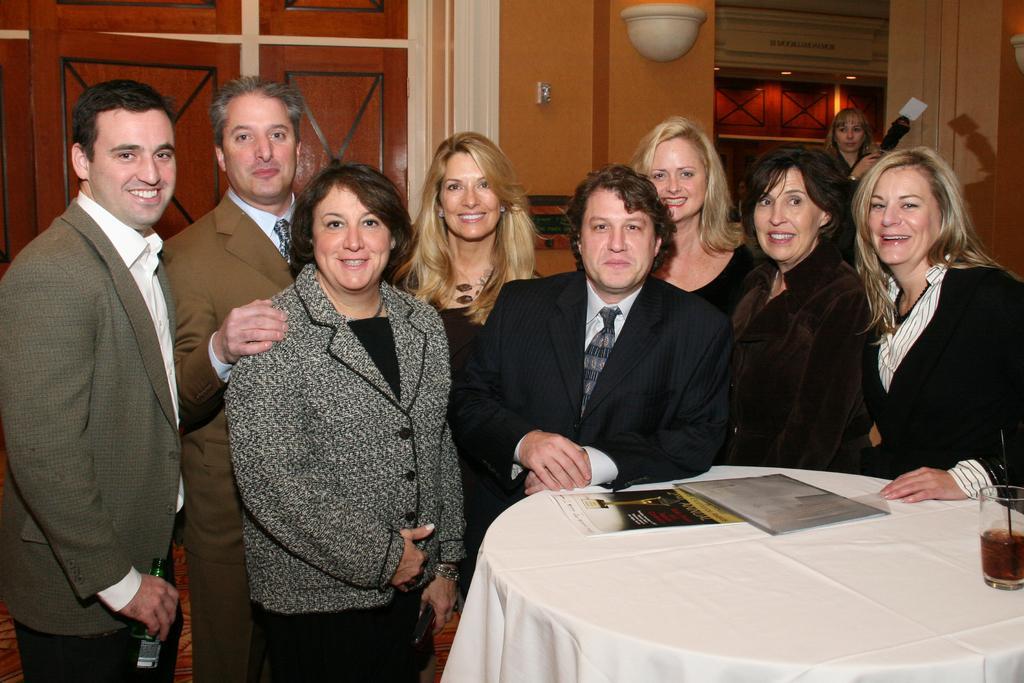Could you give a brief overview of what you see in this image? There are persons in different color dresses, smiling and standing. On the right side, there is a table which is covered with white color cloth, on which there are a glass and documents. In the background, there is another person and there is a wall. 